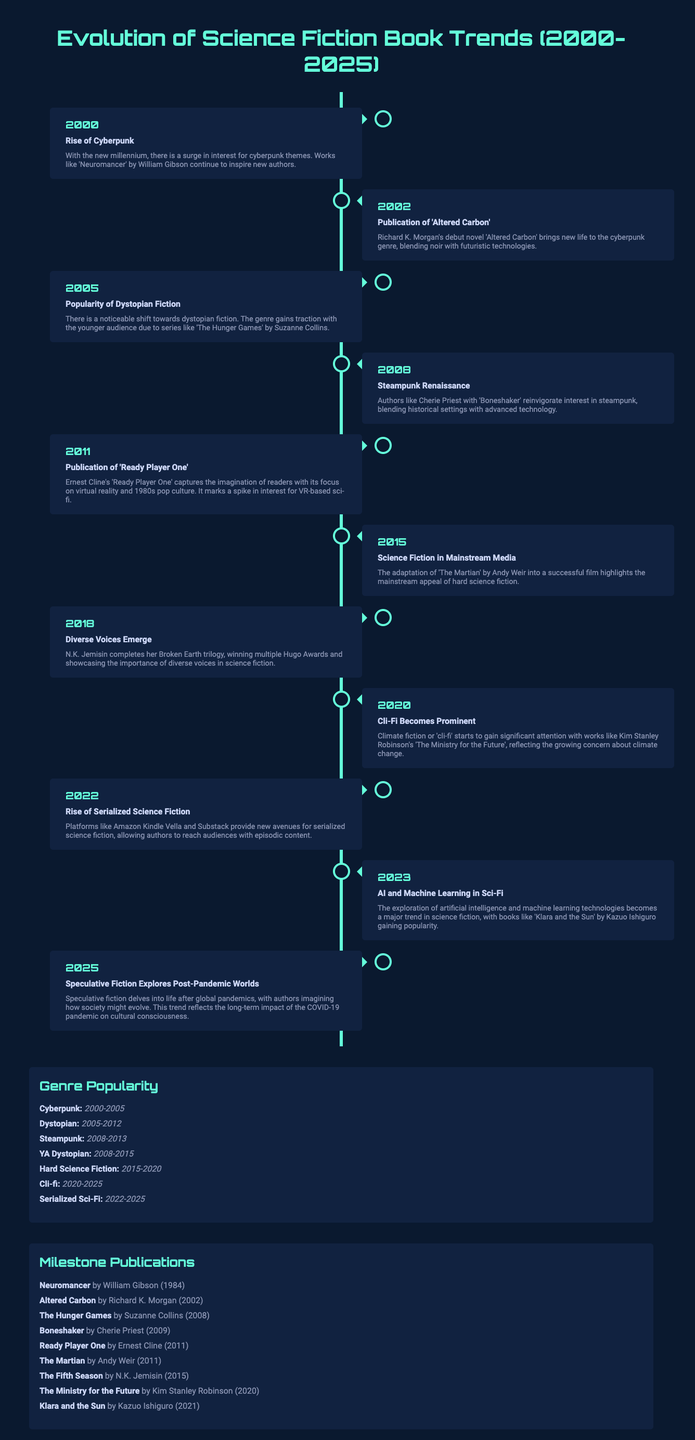What year did the rise of cyberpunk occur? The rise of cyberpunk is noted as taking place in the year 2000.
Answer: 2000 Which book sparked a shift towards dystopian fiction in 2005? The popularity of dystopian fiction in 2005 is attributed to 'The Hunger Games' series by Suzanne Collins.
Answer: The Hunger Games When was 'Ready Player One' published? 'Ready Player One' was published in 2011.
Answer: 2011 What genre peaks from 2020 to 2025? The genre that becomes prominent during this period is cli-fi (climate fiction).
Answer: Cli-fi What significant milestone publication was released in 2020? The significant milestone publication released in 2020 is 'The Ministry for the Future' by Kim Stanley Robinson.
Answer: The Ministry for the Future Which genre had peak popularity years from 2008 to 2015? The genre that peaked in popularity during those years is YA Dystopian.
Answer: YA Dystopian What trend does speculative fiction explore in 2025? Speculative fiction in 2025 explores post-pandemic worlds.
Answer: Post-pandemic worlds Which author completed the Broken Earth trilogy in 2018? The author who completed this trilogy in 2018 is N.K. Jemisin.
Answer: N.K. Jemisin What is the significance of the year 2015 in relation to media? The year 2015 marks the point when science fiction gained mainstream media attention with 'The Martian' adaptation.
Answer: Mainstream media 